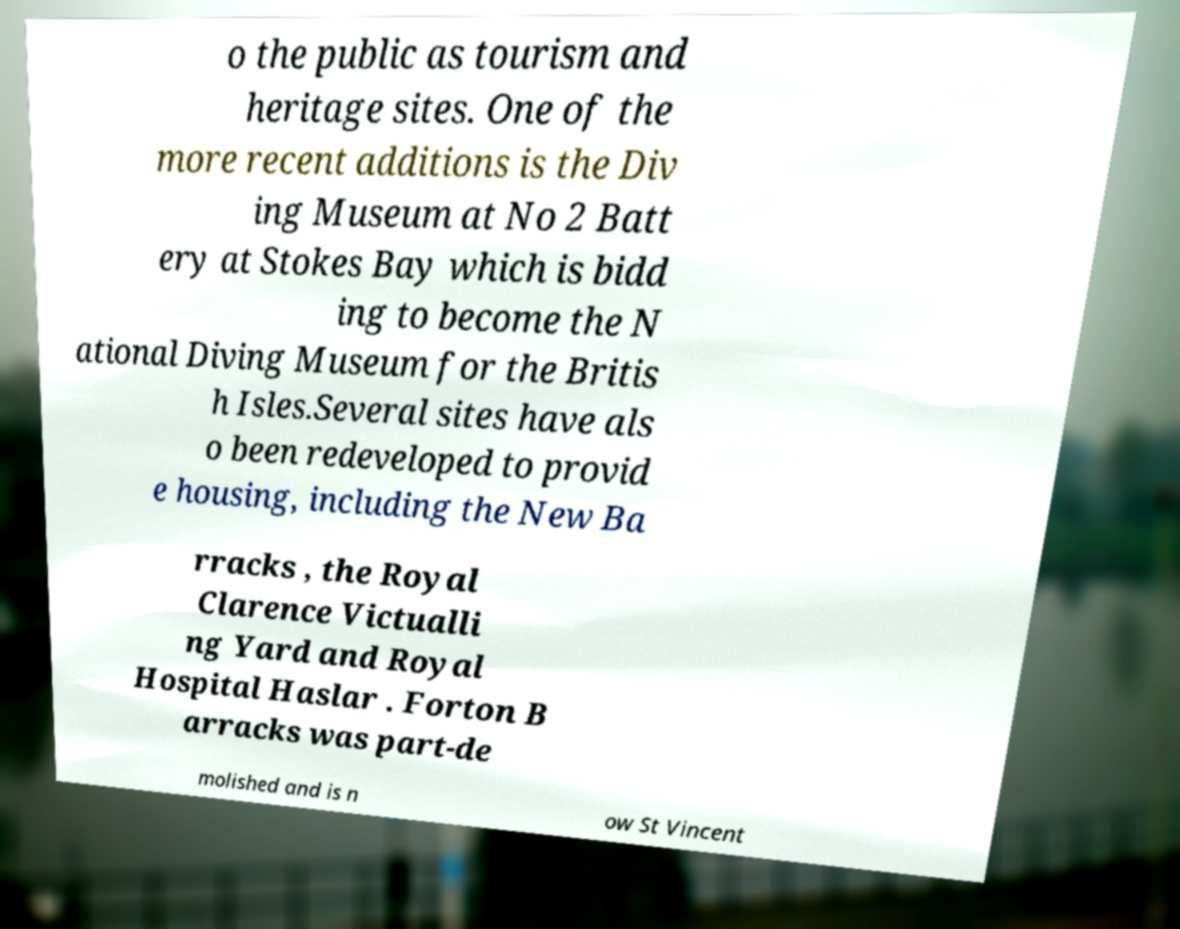Can you read and provide the text displayed in the image?This photo seems to have some interesting text. Can you extract and type it out for me? o the public as tourism and heritage sites. One of the more recent additions is the Div ing Museum at No 2 Batt ery at Stokes Bay which is bidd ing to become the N ational Diving Museum for the Britis h Isles.Several sites have als o been redeveloped to provid e housing, including the New Ba rracks , the Royal Clarence Victualli ng Yard and Royal Hospital Haslar . Forton B arracks was part-de molished and is n ow St Vincent 